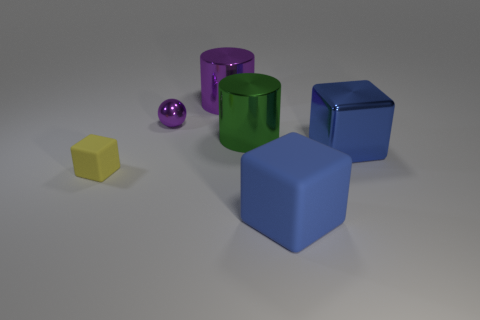Add 2 tiny cubes. How many objects exist? 8 Subtract all spheres. How many objects are left? 5 Add 6 small yellow rubber spheres. How many small yellow rubber spheres exist? 6 Subtract 0 cyan cubes. How many objects are left? 6 Subtract all large rubber cubes. Subtract all small objects. How many objects are left? 3 Add 5 tiny rubber cubes. How many tiny rubber cubes are left? 6 